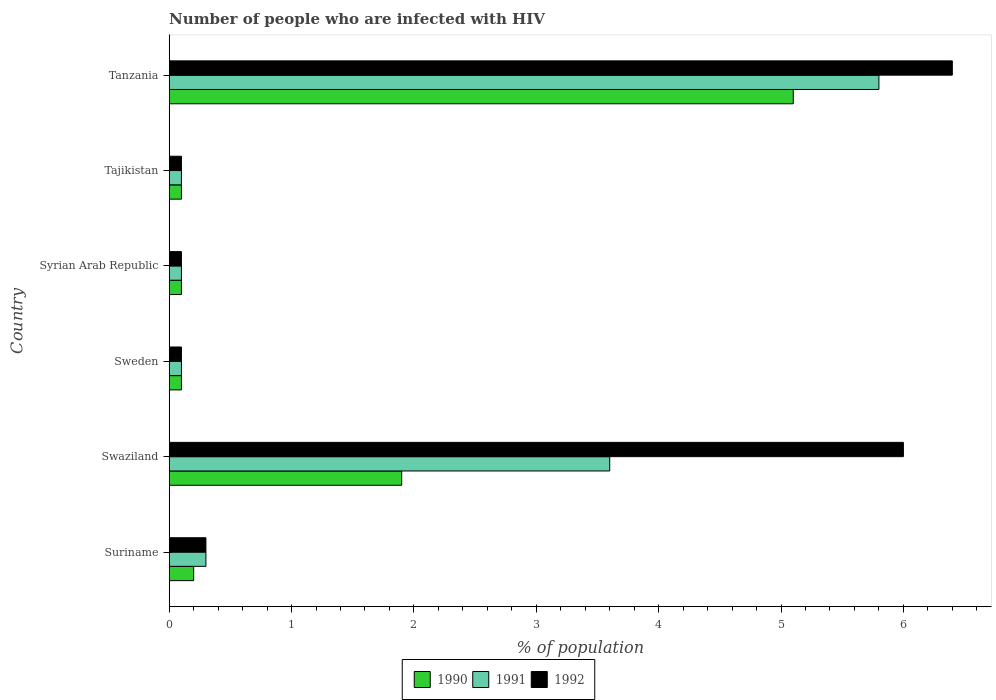How many different coloured bars are there?
Give a very brief answer. 3. Are the number of bars per tick equal to the number of legend labels?
Ensure brevity in your answer.  Yes. Are the number of bars on each tick of the Y-axis equal?
Ensure brevity in your answer.  Yes. How many bars are there on the 3rd tick from the top?
Make the answer very short. 3. How many bars are there on the 4th tick from the bottom?
Offer a very short reply. 3. What is the label of the 6th group of bars from the top?
Your answer should be very brief. Suriname. Across all countries, what is the maximum percentage of HIV infected population in in 1992?
Provide a succinct answer. 6.4. Across all countries, what is the minimum percentage of HIV infected population in in 1992?
Provide a short and direct response. 0.1. In which country was the percentage of HIV infected population in in 1991 maximum?
Ensure brevity in your answer.  Tanzania. In which country was the percentage of HIV infected population in in 1991 minimum?
Offer a terse response. Sweden. What is the total percentage of HIV infected population in in 1992 in the graph?
Ensure brevity in your answer.  13. What is the difference between the percentage of HIV infected population in in 1991 in Suriname and that in Tanzania?
Ensure brevity in your answer.  -5.5. What is the difference between the percentage of HIV infected population in in 1992 in Swaziland and the percentage of HIV infected population in in 1990 in Tajikistan?
Offer a terse response. 5.9. What is the average percentage of HIV infected population in in 1990 per country?
Ensure brevity in your answer.  1.25. What is the difference between the percentage of HIV infected population in in 1990 and percentage of HIV infected population in in 1992 in Tajikistan?
Keep it short and to the point. 0. In how many countries, is the percentage of HIV infected population in in 1990 greater than 2.2 %?
Your answer should be compact. 1. What is the ratio of the percentage of HIV infected population in in 1992 in Tajikistan to that in Tanzania?
Give a very brief answer. 0.02. Is the difference between the percentage of HIV infected population in in 1990 in Suriname and Sweden greater than the difference between the percentage of HIV infected population in in 1992 in Suriname and Sweden?
Provide a short and direct response. No. What is the difference between the highest and the second highest percentage of HIV infected population in in 1990?
Give a very brief answer. 3.2. What is the difference between the highest and the lowest percentage of HIV infected population in in 1990?
Provide a short and direct response. 5. Is the sum of the percentage of HIV infected population in in 1990 in Tajikistan and Tanzania greater than the maximum percentage of HIV infected population in in 1991 across all countries?
Provide a succinct answer. No. What does the 1st bar from the bottom in Syrian Arab Republic represents?
Offer a terse response. 1990. Is it the case that in every country, the sum of the percentage of HIV infected population in in 1992 and percentage of HIV infected population in in 1990 is greater than the percentage of HIV infected population in in 1991?
Make the answer very short. Yes. How many bars are there?
Offer a terse response. 18. How many countries are there in the graph?
Keep it short and to the point. 6. What is the difference between two consecutive major ticks on the X-axis?
Ensure brevity in your answer.  1. Does the graph contain grids?
Your answer should be very brief. No. How many legend labels are there?
Offer a very short reply. 3. How are the legend labels stacked?
Your response must be concise. Horizontal. What is the title of the graph?
Provide a short and direct response. Number of people who are infected with HIV. What is the label or title of the X-axis?
Provide a succinct answer. % of population. What is the % of population of 1990 in Suriname?
Your answer should be very brief. 0.2. What is the % of population of 1991 in Suriname?
Provide a succinct answer. 0.3. What is the % of population of 1992 in Suriname?
Your response must be concise. 0.3. What is the % of population in 1992 in Swaziland?
Make the answer very short. 6. What is the % of population of 1990 in Sweden?
Offer a very short reply. 0.1. What is the % of population of 1992 in Sweden?
Provide a succinct answer. 0.1. What is the % of population in 1991 in Syrian Arab Republic?
Your response must be concise. 0.1. What is the % of population of 1991 in Tajikistan?
Your answer should be very brief. 0.1. What is the % of population of 1992 in Tajikistan?
Your answer should be very brief. 0.1. What is the % of population of 1991 in Tanzania?
Your answer should be very brief. 5.8. What is the % of population in 1992 in Tanzania?
Your answer should be very brief. 6.4. Across all countries, what is the maximum % of population of 1992?
Give a very brief answer. 6.4. Across all countries, what is the minimum % of population in 1990?
Offer a terse response. 0.1. Across all countries, what is the minimum % of population of 1992?
Your answer should be compact. 0.1. What is the total % of population of 1990 in the graph?
Make the answer very short. 7.5. What is the difference between the % of population of 1990 in Suriname and that in Swaziland?
Give a very brief answer. -1.7. What is the difference between the % of population of 1991 in Suriname and that in Swaziland?
Provide a succinct answer. -3.3. What is the difference between the % of population of 1992 in Suriname and that in Swaziland?
Your answer should be compact. -5.7. What is the difference between the % of population of 1990 in Suriname and that in Syrian Arab Republic?
Your response must be concise. 0.1. What is the difference between the % of population of 1991 in Suriname and that in Syrian Arab Republic?
Provide a succinct answer. 0.2. What is the difference between the % of population of 1992 in Suriname and that in Tajikistan?
Offer a very short reply. 0.2. What is the difference between the % of population in 1990 in Swaziland and that in Sweden?
Provide a short and direct response. 1.8. What is the difference between the % of population in 1991 in Swaziland and that in Sweden?
Your response must be concise. 3.5. What is the difference between the % of population of 1990 in Swaziland and that in Syrian Arab Republic?
Your answer should be compact. 1.8. What is the difference between the % of population in 1991 in Swaziland and that in Syrian Arab Republic?
Provide a succinct answer. 3.5. What is the difference between the % of population of 1992 in Swaziland and that in Syrian Arab Republic?
Give a very brief answer. 5.9. What is the difference between the % of population of 1991 in Swaziland and that in Tajikistan?
Give a very brief answer. 3.5. What is the difference between the % of population in 1990 in Swaziland and that in Tanzania?
Ensure brevity in your answer.  -3.2. What is the difference between the % of population in 1992 in Swaziland and that in Tanzania?
Your answer should be very brief. -0.4. What is the difference between the % of population in 1990 in Sweden and that in Syrian Arab Republic?
Offer a terse response. 0. What is the difference between the % of population of 1990 in Sweden and that in Tajikistan?
Your answer should be compact. 0. What is the difference between the % of population in 1991 in Sweden and that in Tajikistan?
Make the answer very short. 0. What is the difference between the % of population of 1992 in Sweden and that in Tajikistan?
Give a very brief answer. 0. What is the difference between the % of population in 1990 in Sweden and that in Tanzania?
Provide a short and direct response. -5. What is the difference between the % of population in 1992 in Sweden and that in Tanzania?
Ensure brevity in your answer.  -6.3. What is the difference between the % of population in 1991 in Syrian Arab Republic and that in Tajikistan?
Your answer should be compact. 0. What is the difference between the % of population of 1991 in Tajikistan and that in Tanzania?
Offer a terse response. -5.7. What is the difference between the % of population in 1992 in Tajikistan and that in Tanzania?
Ensure brevity in your answer.  -6.3. What is the difference between the % of population in 1990 in Suriname and the % of population in 1991 in Swaziland?
Give a very brief answer. -3.4. What is the difference between the % of population in 1990 in Suriname and the % of population in 1991 in Sweden?
Offer a terse response. 0.1. What is the difference between the % of population in 1990 in Suriname and the % of population in 1992 in Tajikistan?
Your answer should be compact. 0.1. What is the difference between the % of population in 1991 in Suriname and the % of population in 1992 in Tajikistan?
Ensure brevity in your answer.  0.2. What is the difference between the % of population of 1990 in Suriname and the % of population of 1991 in Tanzania?
Provide a succinct answer. -5.6. What is the difference between the % of population in 1991 in Swaziland and the % of population in 1992 in Syrian Arab Republic?
Keep it short and to the point. 3.5. What is the difference between the % of population in 1990 in Swaziland and the % of population in 1992 in Tajikistan?
Your answer should be very brief. 1.8. What is the difference between the % of population in 1990 in Swaziland and the % of population in 1992 in Tanzania?
Your answer should be very brief. -4.5. What is the difference between the % of population of 1990 in Sweden and the % of population of 1992 in Syrian Arab Republic?
Make the answer very short. 0. What is the difference between the % of population of 1990 in Sweden and the % of population of 1992 in Tajikistan?
Make the answer very short. 0. What is the difference between the % of population of 1990 in Syrian Arab Republic and the % of population of 1992 in Tajikistan?
Your answer should be very brief. 0. What is the difference between the % of population of 1990 in Tajikistan and the % of population of 1991 in Tanzania?
Make the answer very short. -5.7. What is the difference between the % of population in 1990 in Tajikistan and the % of population in 1992 in Tanzania?
Provide a succinct answer. -6.3. What is the average % of population in 1990 per country?
Offer a terse response. 1.25. What is the average % of population in 1992 per country?
Give a very brief answer. 2.17. What is the difference between the % of population of 1990 and % of population of 1992 in Suriname?
Keep it short and to the point. -0.1. What is the difference between the % of population of 1991 and % of population of 1992 in Swaziland?
Provide a short and direct response. -2.4. What is the difference between the % of population of 1990 and % of population of 1991 in Syrian Arab Republic?
Your answer should be compact. 0. What is the difference between the % of population in 1990 and % of population in 1992 in Syrian Arab Republic?
Offer a very short reply. 0. What is the difference between the % of population in 1991 and % of population in 1992 in Syrian Arab Republic?
Provide a succinct answer. 0. What is the difference between the % of population in 1990 and % of population in 1991 in Tajikistan?
Provide a succinct answer. 0. What is the difference between the % of population of 1990 and % of population of 1991 in Tanzania?
Provide a succinct answer. -0.7. What is the difference between the % of population of 1990 and % of population of 1992 in Tanzania?
Keep it short and to the point. -1.3. What is the ratio of the % of population in 1990 in Suriname to that in Swaziland?
Offer a very short reply. 0.11. What is the ratio of the % of population of 1991 in Suriname to that in Swaziland?
Keep it short and to the point. 0.08. What is the ratio of the % of population in 1992 in Suriname to that in Swaziland?
Your response must be concise. 0.05. What is the ratio of the % of population in 1990 in Suriname to that in Sweden?
Offer a terse response. 2. What is the ratio of the % of population in 1991 in Suriname to that in Sweden?
Offer a terse response. 3. What is the ratio of the % of population of 1990 in Suriname to that in Syrian Arab Republic?
Your answer should be very brief. 2. What is the ratio of the % of population of 1991 in Suriname to that in Syrian Arab Republic?
Provide a short and direct response. 3. What is the ratio of the % of population in 1990 in Suriname to that in Tajikistan?
Ensure brevity in your answer.  2. What is the ratio of the % of population of 1991 in Suriname to that in Tajikistan?
Your answer should be compact. 3. What is the ratio of the % of population of 1992 in Suriname to that in Tajikistan?
Offer a very short reply. 3. What is the ratio of the % of population in 1990 in Suriname to that in Tanzania?
Keep it short and to the point. 0.04. What is the ratio of the % of population of 1991 in Suriname to that in Tanzania?
Provide a short and direct response. 0.05. What is the ratio of the % of population in 1992 in Suriname to that in Tanzania?
Give a very brief answer. 0.05. What is the ratio of the % of population of 1991 in Swaziland to that in Sweden?
Offer a very short reply. 36. What is the ratio of the % of population of 1991 in Swaziland to that in Syrian Arab Republic?
Make the answer very short. 36. What is the ratio of the % of population in 1992 in Swaziland to that in Syrian Arab Republic?
Make the answer very short. 60. What is the ratio of the % of population in 1990 in Swaziland to that in Tajikistan?
Provide a short and direct response. 19. What is the ratio of the % of population in 1990 in Swaziland to that in Tanzania?
Your answer should be very brief. 0.37. What is the ratio of the % of population in 1991 in Swaziland to that in Tanzania?
Provide a succinct answer. 0.62. What is the ratio of the % of population in 1990 in Sweden to that in Syrian Arab Republic?
Offer a very short reply. 1. What is the ratio of the % of population in 1992 in Sweden to that in Syrian Arab Republic?
Your answer should be very brief. 1. What is the ratio of the % of population of 1992 in Sweden to that in Tajikistan?
Offer a very short reply. 1. What is the ratio of the % of population in 1990 in Sweden to that in Tanzania?
Provide a succinct answer. 0.02. What is the ratio of the % of population in 1991 in Sweden to that in Tanzania?
Your response must be concise. 0.02. What is the ratio of the % of population of 1992 in Sweden to that in Tanzania?
Offer a terse response. 0.02. What is the ratio of the % of population of 1991 in Syrian Arab Republic to that in Tajikistan?
Give a very brief answer. 1. What is the ratio of the % of population of 1990 in Syrian Arab Republic to that in Tanzania?
Provide a succinct answer. 0.02. What is the ratio of the % of population in 1991 in Syrian Arab Republic to that in Tanzania?
Your response must be concise. 0.02. What is the ratio of the % of population in 1992 in Syrian Arab Republic to that in Tanzania?
Your answer should be very brief. 0.02. What is the ratio of the % of population of 1990 in Tajikistan to that in Tanzania?
Offer a very short reply. 0.02. What is the ratio of the % of population in 1991 in Tajikistan to that in Tanzania?
Ensure brevity in your answer.  0.02. What is the ratio of the % of population of 1992 in Tajikistan to that in Tanzania?
Provide a short and direct response. 0.02. 